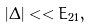Convert formula to latex. <formula><loc_0><loc_0><loc_500><loc_500>\left | \Delta \right | < < E _ { 2 1 } ,</formula> 